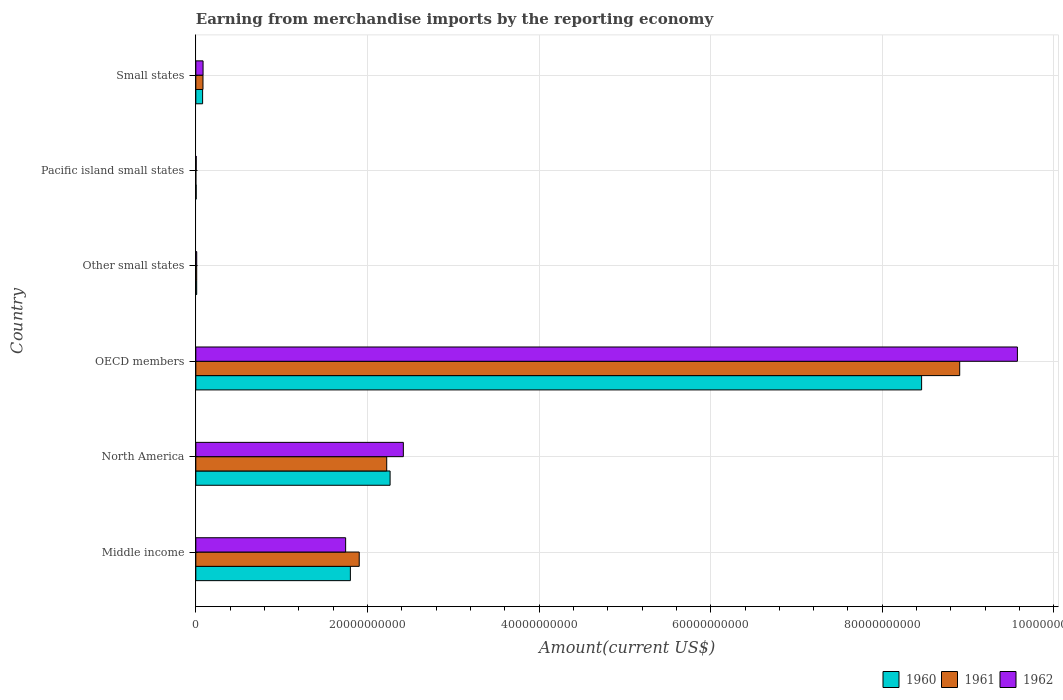How many different coloured bars are there?
Offer a terse response. 3. Are the number of bars per tick equal to the number of legend labels?
Make the answer very short. Yes. Are the number of bars on each tick of the Y-axis equal?
Your answer should be very brief. Yes. How many bars are there on the 6th tick from the top?
Offer a very short reply. 3. How many bars are there on the 2nd tick from the bottom?
Make the answer very short. 3. What is the label of the 5th group of bars from the top?
Keep it short and to the point. North America. What is the amount earned from merchandise imports in 1960 in Pacific island small states?
Give a very brief answer. 4.12e+07. Across all countries, what is the maximum amount earned from merchandise imports in 1960?
Keep it short and to the point. 8.46e+1. Across all countries, what is the minimum amount earned from merchandise imports in 1960?
Keep it short and to the point. 4.12e+07. In which country was the amount earned from merchandise imports in 1960 minimum?
Offer a terse response. Pacific island small states. What is the total amount earned from merchandise imports in 1962 in the graph?
Your response must be concise. 1.38e+11. What is the difference between the amount earned from merchandise imports in 1961 in North America and that in Small states?
Offer a very short reply. 2.14e+1. What is the difference between the amount earned from merchandise imports in 1962 in Other small states and the amount earned from merchandise imports in 1961 in OECD members?
Your answer should be compact. -8.89e+1. What is the average amount earned from merchandise imports in 1961 per country?
Offer a very short reply. 2.19e+1. In how many countries, is the amount earned from merchandise imports in 1960 greater than 92000000000 US$?
Your answer should be very brief. 0. What is the ratio of the amount earned from merchandise imports in 1961 in Middle income to that in Small states?
Provide a short and direct response. 22.84. What is the difference between the highest and the second highest amount earned from merchandise imports in 1961?
Your answer should be very brief. 6.68e+1. What is the difference between the highest and the lowest amount earned from merchandise imports in 1962?
Give a very brief answer. 9.57e+1. What does the 1st bar from the top in Other small states represents?
Provide a succinct answer. 1962. Is it the case that in every country, the sum of the amount earned from merchandise imports in 1960 and amount earned from merchandise imports in 1961 is greater than the amount earned from merchandise imports in 1962?
Your answer should be very brief. No. Are all the bars in the graph horizontal?
Your response must be concise. Yes. Does the graph contain grids?
Make the answer very short. Yes. How many legend labels are there?
Your answer should be very brief. 3. How are the legend labels stacked?
Ensure brevity in your answer.  Horizontal. What is the title of the graph?
Give a very brief answer. Earning from merchandise imports by the reporting economy. What is the label or title of the X-axis?
Your answer should be very brief. Amount(current US$). What is the Amount(current US$) in 1960 in Middle income?
Your answer should be very brief. 1.80e+1. What is the Amount(current US$) in 1961 in Middle income?
Your answer should be compact. 1.90e+1. What is the Amount(current US$) in 1962 in Middle income?
Make the answer very short. 1.75e+1. What is the Amount(current US$) of 1960 in North America?
Provide a short and direct response. 2.26e+1. What is the Amount(current US$) of 1961 in North America?
Ensure brevity in your answer.  2.22e+1. What is the Amount(current US$) in 1962 in North America?
Your response must be concise. 2.42e+1. What is the Amount(current US$) of 1960 in OECD members?
Provide a short and direct response. 8.46e+1. What is the Amount(current US$) in 1961 in OECD members?
Ensure brevity in your answer.  8.90e+1. What is the Amount(current US$) in 1962 in OECD members?
Provide a short and direct response. 9.57e+1. What is the Amount(current US$) of 1960 in Other small states?
Make the answer very short. 1.00e+08. What is the Amount(current US$) in 1961 in Other small states?
Provide a succinct answer. 1.02e+08. What is the Amount(current US$) of 1962 in Other small states?
Ensure brevity in your answer.  1.04e+08. What is the Amount(current US$) in 1960 in Pacific island small states?
Your answer should be compact. 4.12e+07. What is the Amount(current US$) in 1961 in Pacific island small states?
Ensure brevity in your answer.  1.20e+06. What is the Amount(current US$) of 1962 in Pacific island small states?
Ensure brevity in your answer.  4.33e+07. What is the Amount(current US$) in 1960 in Small states?
Give a very brief answer. 7.90e+08. What is the Amount(current US$) of 1961 in Small states?
Offer a terse response. 8.34e+08. What is the Amount(current US$) in 1962 in Small states?
Make the answer very short. 8.44e+08. Across all countries, what is the maximum Amount(current US$) in 1960?
Your answer should be very brief. 8.46e+1. Across all countries, what is the maximum Amount(current US$) of 1961?
Ensure brevity in your answer.  8.90e+1. Across all countries, what is the maximum Amount(current US$) of 1962?
Offer a terse response. 9.57e+1. Across all countries, what is the minimum Amount(current US$) of 1960?
Make the answer very short. 4.12e+07. Across all countries, what is the minimum Amount(current US$) in 1961?
Offer a terse response. 1.20e+06. Across all countries, what is the minimum Amount(current US$) of 1962?
Provide a succinct answer. 4.33e+07. What is the total Amount(current US$) of 1960 in the graph?
Your answer should be compact. 1.26e+11. What is the total Amount(current US$) of 1961 in the graph?
Give a very brief answer. 1.31e+11. What is the total Amount(current US$) of 1962 in the graph?
Make the answer very short. 1.38e+11. What is the difference between the Amount(current US$) of 1960 in Middle income and that in North America?
Your answer should be very brief. -4.63e+09. What is the difference between the Amount(current US$) in 1961 in Middle income and that in North America?
Offer a very short reply. -3.20e+09. What is the difference between the Amount(current US$) in 1962 in Middle income and that in North America?
Offer a terse response. -6.72e+09. What is the difference between the Amount(current US$) in 1960 in Middle income and that in OECD members?
Provide a succinct answer. -6.66e+1. What is the difference between the Amount(current US$) in 1961 in Middle income and that in OECD members?
Offer a very short reply. -7.00e+1. What is the difference between the Amount(current US$) in 1962 in Middle income and that in OECD members?
Make the answer very short. -7.83e+1. What is the difference between the Amount(current US$) in 1960 in Middle income and that in Other small states?
Give a very brief answer. 1.79e+1. What is the difference between the Amount(current US$) of 1961 in Middle income and that in Other small states?
Offer a very short reply. 1.89e+1. What is the difference between the Amount(current US$) of 1962 in Middle income and that in Other small states?
Your answer should be very brief. 1.74e+1. What is the difference between the Amount(current US$) in 1960 in Middle income and that in Pacific island small states?
Provide a succinct answer. 1.80e+1. What is the difference between the Amount(current US$) of 1961 in Middle income and that in Pacific island small states?
Your answer should be very brief. 1.90e+1. What is the difference between the Amount(current US$) in 1962 in Middle income and that in Pacific island small states?
Make the answer very short. 1.74e+1. What is the difference between the Amount(current US$) in 1960 in Middle income and that in Small states?
Offer a very short reply. 1.72e+1. What is the difference between the Amount(current US$) of 1961 in Middle income and that in Small states?
Offer a very short reply. 1.82e+1. What is the difference between the Amount(current US$) of 1962 in Middle income and that in Small states?
Your answer should be compact. 1.66e+1. What is the difference between the Amount(current US$) of 1960 in North America and that in OECD members?
Keep it short and to the point. -6.19e+1. What is the difference between the Amount(current US$) in 1961 in North America and that in OECD members?
Your answer should be compact. -6.68e+1. What is the difference between the Amount(current US$) in 1962 in North America and that in OECD members?
Keep it short and to the point. -7.16e+1. What is the difference between the Amount(current US$) in 1960 in North America and that in Other small states?
Your answer should be very brief. 2.25e+1. What is the difference between the Amount(current US$) of 1961 in North America and that in Other small states?
Your answer should be very brief. 2.21e+1. What is the difference between the Amount(current US$) in 1962 in North America and that in Other small states?
Your answer should be very brief. 2.41e+1. What is the difference between the Amount(current US$) in 1960 in North America and that in Pacific island small states?
Your answer should be very brief. 2.26e+1. What is the difference between the Amount(current US$) in 1961 in North America and that in Pacific island small states?
Ensure brevity in your answer.  2.22e+1. What is the difference between the Amount(current US$) of 1962 in North America and that in Pacific island small states?
Your answer should be very brief. 2.41e+1. What is the difference between the Amount(current US$) in 1960 in North America and that in Small states?
Provide a short and direct response. 2.18e+1. What is the difference between the Amount(current US$) in 1961 in North America and that in Small states?
Keep it short and to the point. 2.14e+1. What is the difference between the Amount(current US$) in 1962 in North America and that in Small states?
Your answer should be very brief. 2.33e+1. What is the difference between the Amount(current US$) in 1960 in OECD members and that in Other small states?
Your response must be concise. 8.45e+1. What is the difference between the Amount(current US$) of 1961 in OECD members and that in Other small states?
Your answer should be very brief. 8.89e+1. What is the difference between the Amount(current US$) of 1962 in OECD members and that in Other small states?
Provide a short and direct response. 9.56e+1. What is the difference between the Amount(current US$) of 1960 in OECD members and that in Pacific island small states?
Offer a terse response. 8.45e+1. What is the difference between the Amount(current US$) of 1961 in OECD members and that in Pacific island small states?
Ensure brevity in your answer.  8.90e+1. What is the difference between the Amount(current US$) of 1962 in OECD members and that in Pacific island small states?
Your answer should be very brief. 9.57e+1. What is the difference between the Amount(current US$) in 1960 in OECD members and that in Small states?
Your answer should be very brief. 8.38e+1. What is the difference between the Amount(current US$) in 1961 in OECD members and that in Small states?
Provide a short and direct response. 8.82e+1. What is the difference between the Amount(current US$) in 1962 in OECD members and that in Small states?
Give a very brief answer. 9.49e+1. What is the difference between the Amount(current US$) of 1960 in Other small states and that in Pacific island small states?
Provide a succinct answer. 5.90e+07. What is the difference between the Amount(current US$) of 1961 in Other small states and that in Pacific island small states?
Provide a succinct answer. 1.00e+08. What is the difference between the Amount(current US$) of 1962 in Other small states and that in Pacific island small states?
Provide a short and direct response. 6.08e+07. What is the difference between the Amount(current US$) in 1960 in Other small states and that in Small states?
Your answer should be compact. -6.90e+08. What is the difference between the Amount(current US$) in 1961 in Other small states and that in Small states?
Provide a short and direct response. -7.32e+08. What is the difference between the Amount(current US$) in 1962 in Other small states and that in Small states?
Provide a short and direct response. -7.40e+08. What is the difference between the Amount(current US$) of 1960 in Pacific island small states and that in Small states?
Your response must be concise. -7.49e+08. What is the difference between the Amount(current US$) of 1961 in Pacific island small states and that in Small states?
Provide a short and direct response. -8.32e+08. What is the difference between the Amount(current US$) of 1962 in Pacific island small states and that in Small states?
Provide a succinct answer. -8.00e+08. What is the difference between the Amount(current US$) of 1960 in Middle income and the Amount(current US$) of 1961 in North America?
Keep it short and to the point. -4.23e+09. What is the difference between the Amount(current US$) of 1960 in Middle income and the Amount(current US$) of 1962 in North America?
Give a very brief answer. -6.17e+09. What is the difference between the Amount(current US$) in 1961 in Middle income and the Amount(current US$) in 1962 in North America?
Your answer should be very brief. -5.14e+09. What is the difference between the Amount(current US$) in 1960 in Middle income and the Amount(current US$) in 1961 in OECD members?
Ensure brevity in your answer.  -7.10e+1. What is the difference between the Amount(current US$) of 1960 in Middle income and the Amount(current US$) of 1962 in OECD members?
Give a very brief answer. -7.77e+1. What is the difference between the Amount(current US$) of 1961 in Middle income and the Amount(current US$) of 1962 in OECD members?
Provide a short and direct response. -7.67e+1. What is the difference between the Amount(current US$) of 1960 in Middle income and the Amount(current US$) of 1961 in Other small states?
Keep it short and to the point. 1.79e+1. What is the difference between the Amount(current US$) of 1960 in Middle income and the Amount(current US$) of 1962 in Other small states?
Ensure brevity in your answer.  1.79e+1. What is the difference between the Amount(current US$) of 1961 in Middle income and the Amount(current US$) of 1962 in Other small states?
Your response must be concise. 1.89e+1. What is the difference between the Amount(current US$) of 1960 in Middle income and the Amount(current US$) of 1961 in Pacific island small states?
Make the answer very short. 1.80e+1. What is the difference between the Amount(current US$) in 1960 in Middle income and the Amount(current US$) in 1962 in Pacific island small states?
Your answer should be compact. 1.80e+1. What is the difference between the Amount(current US$) in 1961 in Middle income and the Amount(current US$) in 1962 in Pacific island small states?
Keep it short and to the point. 1.90e+1. What is the difference between the Amount(current US$) in 1960 in Middle income and the Amount(current US$) in 1961 in Small states?
Offer a terse response. 1.72e+1. What is the difference between the Amount(current US$) of 1960 in Middle income and the Amount(current US$) of 1962 in Small states?
Your response must be concise. 1.72e+1. What is the difference between the Amount(current US$) in 1961 in Middle income and the Amount(current US$) in 1962 in Small states?
Your response must be concise. 1.82e+1. What is the difference between the Amount(current US$) of 1960 in North America and the Amount(current US$) of 1961 in OECD members?
Offer a terse response. -6.64e+1. What is the difference between the Amount(current US$) in 1960 in North America and the Amount(current US$) in 1962 in OECD members?
Provide a short and direct response. -7.31e+1. What is the difference between the Amount(current US$) of 1961 in North America and the Amount(current US$) of 1962 in OECD members?
Offer a terse response. -7.35e+1. What is the difference between the Amount(current US$) of 1960 in North America and the Amount(current US$) of 1961 in Other small states?
Offer a very short reply. 2.25e+1. What is the difference between the Amount(current US$) of 1960 in North America and the Amount(current US$) of 1962 in Other small states?
Give a very brief answer. 2.25e+1. What is the difference between the Amount(current US$) of 1961 in North America and the Amount(current US$) of 1962 in Other small states?
Your answer should be very brief. 2.21e+1. What is the difference between the Amount(current US$) in 1960 in North America and the Amount(current US$) in 1961 in Pacific island small states?
Make the answer very short. 2.26e+1. What is the difference between the Amount(current US$) in 1960 in North America and the Amount(current US$) in 1962 in Pacific island small states?
Your response must be concise. 2.26e+1. What is the difference between the Amount(current US$) of 1961 in North America and the Amount(current US$) of 1962 in Pacific island small states?
Provide a succinct answer. 2.22e+1. What is the difference between the Amount(current US$) of 1960 in North America and the Amount(current US$) of 1961 in Small states?
Ensure brevity in your answer.  2.18e+1. What is the difference between the Amount(current US$) in 1960 in North America and the Amount(current US$) in 1962 in Small states?
Your answer should be very brief. 2.18e+1. What is the difference between the Amount(current US$) of 1961 in North America and the Amount(current US$) of 1962 in Small states?
Provide a short and direct response. 2.14e+1. What is the difference between the Amount(current US$) in 1960 in OECD members and the Amount(current US$) in 1961 in Other small states?
Make the answer very short. 8.45e+1. What is the difference between the Amount(current US$) in 1960 in OECD members and the Amount(current US$) in 1962 in Other small states?
Offer a terse response. 8.45e+1. What is the difference between the Amount(current US$) of 1961 in OECD members and the Amount(current US$) of 1962 in Other small states?
Make the answer very short. 8.89e+1. What is the difference between the Amount(current US$) of 1960 in OECD members and the Amount(current US$) of 1961 in Pacific island small states?
Your answer should be very brief. 8.46e+1. What is the difference between the Amount(current US$) in 1960 in OECD members and the Amount(current US$) in 1962 in Pacific island small states?
Keep it short and to the point. 8.45e+1. What is the difference between the Amount(current US$) of 1961 in OECD members and the Amount(current US$) of 1962 in Pacific island small states?
Provide a short and direct response. 8.90e+1. What is the difference between the Amount(current US$) of 1960 in OECD members and the Amount(current US$) of 1961 in Small states?
Make the answer very short. 8.37e+1. What is the difference between the Amount(current US$) of 1960 in OECD members and the Amount(current US$) of 1962 in Small states?
Ensure brevity in your answer.  8.37e+1. What is the difference between the Amount(current US$) of 1961 in OECD members and the Amount(current US$) of 1962 in Small states?
Make the answer very short. 8.82e+1. What is the difference between the Amount(current US$) in 1960 in Other small states and the Amount(current US$) in 1961 in Pacific island small states?
Provide a short and direct response. 9.90e+07. What is the difference between the Amount(current US$) of 1960 in Other small states and the Amount(current US$) of 1962 in Pacific island small states?
Ensure brevity in your answer.  5.69e+07. What is the difference between the Amount(current US$) in 1961 in Other small states and the Amount(current US$) in 1962 in Pacific island small states?
Keep it short and to the point. 5.84e+07. What is the difference between the Amount(current US$) of 1960 in Other small states and the Amount(current US$) of 1961 in Small states?
Provide a succinct answer. -7.34e+08. What is the difference between the Amount(current US$) in 1960 in Other small states and the Amount(current US$) in 1962 in Small states?
Ensure brevity in your answer.  -7.44e+08. What is the difference between the Amount(current US$) of 1961 in Other small states and the Amount(current US$) of 1962 in Small states?
Offer a very short reply. -7.42e+08. What is the difference between the Amount(current US$) in 1960 in Pacific island small states and the Amount(current US$) in 1961 in Small states?
Provide a succinct answer. -7.92e+08. What is the difference between the Amount(current US$) of 1960 in Pacific island small states and the Amount(current US$) of 1962 in Small states?
Keep it short and to the point. -8.02e+08. What is the difference between the Amount(current US$) of 1961 in Pacific island small states and the Amount(current US$) of 1962 in Small states?
Your answer should be very brief. -8.42e+08. What is the average Amount(current US$) in 1960 per country?
Make the answer very short. 2.10e+1. What is the average Amount(current US$) in 1961 per country?
Provide a succinct answer. 2.19e+1. What is the average Amount(current US$) in 1962 per country?
Keep it short and to the point. 2.31e+1. What is the difference between the Amount(current US$) in 1960 and Amount(current US$) in 1961 in Middle income?
Your response must be concise. -1.03e+09. What is the difference between the Amount(current US$) of 1960 and Amount(current US$) of 1962 in Middle income?
Make the answer very short. 5.52e+08. What is the difference between the Amount(current US$) in 1961 and Amount(current US$) in 1962 in Middle income?
Make the answer very short. 1.58e+09. What is the difference between the Amount(current US$) of 1960 and Amount(current US$) of 1961 in North America?
Offer a very short reply. 3.93e+08. What is the difference between the Amount(current US$) of 1960 and Amount(current US$) of 1962 in North America?
Give a very brief answer. -1.54e+09. What is the difference between the Amount(current US$) of 1961 and Amount(current US$) of 1962 in North America?
Ensure brevity in your answer.  -1.94e+09. What is the difference between the Amount(current US$) in 1960 and Amount(current US$) in 1961 in OECD members?
Your answer should be compact. -4.44e+09. What is the difference between the Amount(current US$) of 1960 and Amount(current US$) of 1962 in OECD members?
Give a very brief answer. -1.12e+1. What is the difference between the Amount(current US$) in 1961 and Amount(current US$) in 1962 in OECD members?
Your answer should be very brief. -6.73e+09. What is the difference between the Amount(current US$) in 1960 and Amount(current US$) in 1961 in Other small states?
Your answer should be compact. -1.50e+06. What is the difference between the Amount(current US$) in 1960 and Amount(current US$) in 1962 in Other small states?
Offer a very short reply. -3.90e+06. What is the difference between the Amount(current US$) of 1961 and Amount(current US$) of 1962 in Other small states?
Your answer should be very brief. -2.40e+06. What is the difference between the Amount(current US$) in 1960 and Amount(current US$) in 1961 in Pacific island small states?
Give a very brief answer. 4.00e+07. What is the difference between the Amount(current US$) of 1960 and Amount(current US$) of 1962 in Pacific island small states?
Your answer should be very brief. -2.10e+06. What is the difference between the Amount(current US$) of 1961 and Amount(current US$) of 1962 in Pacific island small states?
Your response must be concise. -4.21e+07. What is the difference between the Amount(current US$) in 1960 and Amount(current US$) in 1961 in Small states?
Provide a short and direct response. -4.33e+07. What is the difference between the Amount(current US$) of 1960 and Amount(current US$) of 1962 in Small states?
Make the answer very short. -5.33e+07. What is the difference between the Amount(current US$) in 1961 and Amount(current US$) in 1962 in Small states?
Your response must be concise. -1.00e+07. What is the ratio of the Amount(current US$) in 1960 in Middle income to that in North America?
Your answer should be compact. 0.8. What is the ratio of the Amount(current US$) in 1961 in Middle income to that in North America?
Offer a terse response. 0.86. What is the ratio of the Amount(current US$) of 1962 in Middle income to that in North America?
Ensure brevity in your answer.  0.72. What is the ratio of the Amount(current US$) of 1960 in Middle income to that in OECD members?
Offer a terse response. 0.21. What is the ratio of the Amount(current US$) in 1961 in Middle income to that in OECD members?
Keep it short and to the point. 0.21. What is the ratio of the Amount(current US$) in 1962 in Middle income to that in OECD members?
Ensure brevity in your answer.  0.18. What is the ratio of the Amount(current US$) of 1960 in Middle income to that in Other small states?
Make the answer very short. 179.75. What is the ratio of the Amount(current US$) in 1961 in Middle income to that in Other small states?
Your answer should be very brief. 187.24. What is the ratio of the Amount(current US$) of 1962 in Middle income to that in Other small states?
Your answer should be very brief. 167.72. What is the ratio of the Amount(current US$) of 1960 in Middle income to that in Pacific island small states?
Your answer should be very brief. 437.16. What is the ratio of the Amount(current US$) of 1961 in Middle income to that in Pacific island small states?
Make the answer very short. 1.59e+04. What is the ratio of the Amount(current US$) in 1962 in Middle income to that in Pacific island small states?
Make the answer very short. 403.22. What is the ratio of the Amount(current US$) in 1960 in Middle income to that in Small states?
Provide a short and direct response. 22.79. What is the ratio of the Amount(current US$) in 1961 in Middle income to that in Small states?
Your response must be concise. 22.84. What is the ratio of the Amount(current US$) in 1962 in Middle income to that in Small states?
Your answer should be very brief. 20.69. What is the ratio of the Amount(current US$) of 1960 in North America to that in OECD members?
Make the answer very short. 0.27. What is the ratio of the Amount(current US$) in 1961 in North America to that in OECD members?
Provide a short and direct response. 0.25. What is the ratio of the Amount(current US$) of 1962 in North America to that in OECD members?
Offer a very short reply. 0.25. What is the ratio of the Amount(current US$) of 1960 in North America to that in Other small states?
Offer a very short reply. 225.94. What is the ratio of the Amount(current US$) of 1961 in North America to that in Other small states?
Offer a very short reply. 218.74. What is the ratio of the Amount(current US$) in 1962 in North America to that in Other small states?
Provide a succinct answer. 232.31. What is the ratio of the Amount(current US$) of 1960 in North America to that in Pacific island small states?
Offer a very short reply. 549.48. What is the ratio of the Amount(current US$) in 1961 in North America to that in Pacific island small states?
Provide a short and direct response. 1.85e+04. What is the ratio of the Amount(current US$) of 1962 in North America to that in Pacific island small states?
Give a very brief answer. 558.51. What is the ratio of the Amount(current US$) in 1960 in North America to that in Small states?
Provide a succinct answer. 28.64. What is the ratio of the Amount(current US$) in 1961 in North America to that in Small states?
Provide a short and direct response. 26.68. What is the ratio of the Amount(current US$) of 1962 in North America to that in Small states?
Provide a short and direct response. 28.66. What is the ratio of the Amount(current US$) of 1960 in OECD members to that in Other small states?
Your answer should be very brief. 844.13. What is the ratio of the Amount(current US$) of 1961 in OECD members to that in Other small states?
Provide a short and direct response. 875.34. What is the ratio of the Amount(current US$) of 1962 in OECD members to that in Other small states?
Make the answer very short. 919.76. What is the ratio of the Amount(current US$) of 1960 in OECD members to that in Pacific island small states?
Provide a succinct answer. 2052.96. What is the ratio of the Amount(current US$) in 1961 in OECD members to that in Pacific island small states?
Provide a succinct answer. 7.42e+04. What is the ratio of the Amount(current US$) in 1962 in OECD members to that in Pacific island small states?
Your answer should be compact. 2211.24. What is the ratio of the Amount(current US$) of 1960 in OECD members to that in Small states?
Offer a terse response. 107.01. What is the ratio of the Amount(current US$) in 1961 in OECD members to that in Small states?
Provide a short and direct response. 106.78. What is the ratio of the Amount(current US$) of 1962 in OECD members to that in Small states?
Ensure brevity in your answer.  113.48. What is the ratio of the Amount(current US$) in 1960 in Other small states to that in Pacific island small states?
Give a very brief answer. 2.43. What is the ratio of the Amount(current US$) of 1961 in Other small states to that in Pacific island small states?
Your answer should be very brief. 84.75. What is the ratio of the Amount(current US$) of 1962 in Other small states to that in Pacific island small states?
Keep it short and to the point. 2.4. What is the ratio of the Amount(current US$) in 1960 in Other small states to that in Small states?
Give a very brief answer. 0.13. What is the ratio of the Amount(current US$) of 1961 in Other small states to that in Small states?
Your answer should be very brief. 0.12. What is the ratio of the Amount(current US$) of 1962 in Other small states to that in Small states?
Your response must be concise. 0.12. What is the ratio of the Amount(current US$) in 1960 in Pacific island small states to that in Small states?
Make the answer very short. 0.05. What is the ratio of the Amount(current US$) of 1961 in Pacific island small states to that in Small states?
Provide a succinct answer. 0. What is the ratio of the Amount(current US$) of 1962 in Pacific island small states to that in Small states?
Your answer should be very brief. 0.05. What is the difference between the highest and the second highest Amount(current US$) in 1960?
Offer a very short reply. 6.19e+1. What is the difference between the highest and the second highest Amount(current US$) of 1961?
Your answer should be compact. 6.68e+1. What is the difference between the highest and the second highest Amount(current US$) of 1962?
Offer a very short reply. 7.16e+1. What is the difference between the highest and the lowest Amount(current US$) in 1960?
Keep it short and to the point. 8.45e+1. What is the difference between the highest and the lowest Amount(current US$) in 1961?
Your response must be concise. 8.90e+1. What is the difference between the highest and the lowest Amount(current US$) in 1962?
Provide a succinct answer. 9.57e+1. 